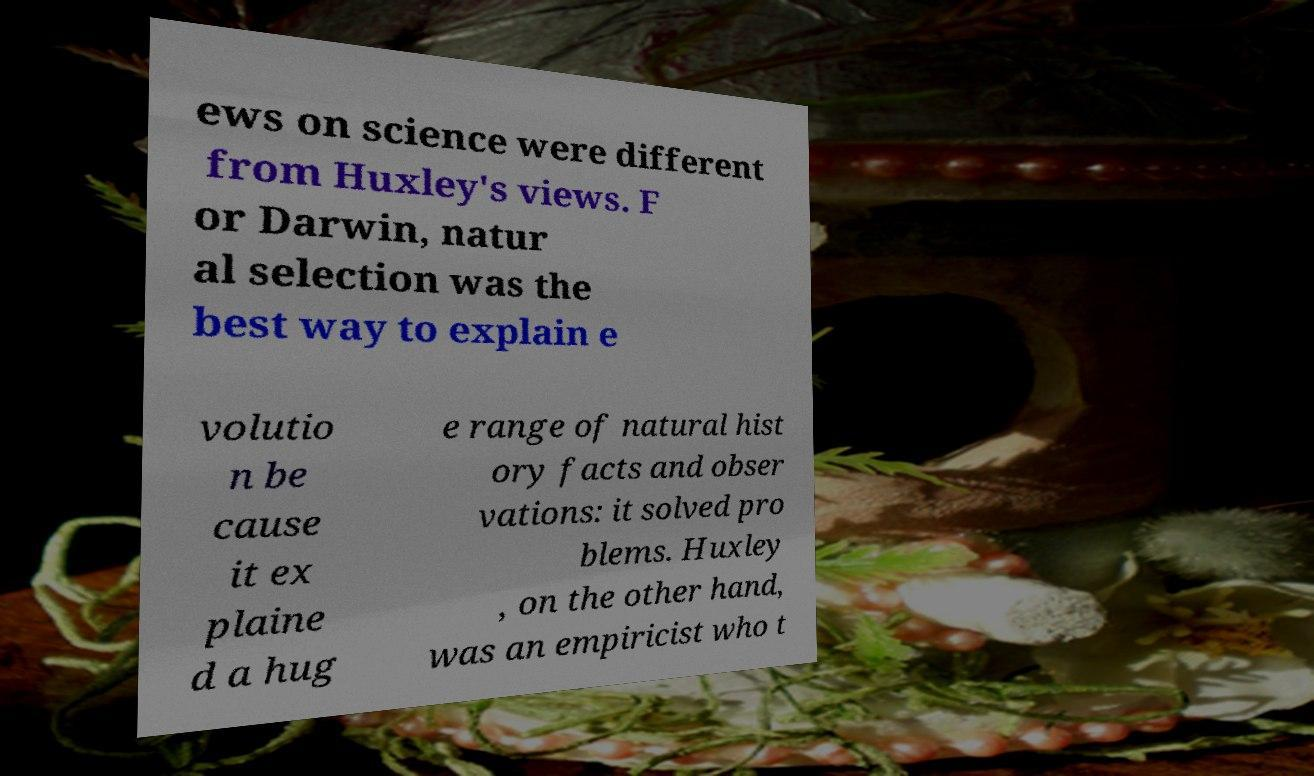There's text embedded in this image that I need extracted. Can you transcribe it verbatim? ews on science were different from Huxley's views. F or Darwin, natur al selection was the best way to explain e volutio n be cause it ex plaine d a hug e range of natural hist ory facts and obser vations: it solved pro blems. Huxley , on the other hand, was an empiricist who t 